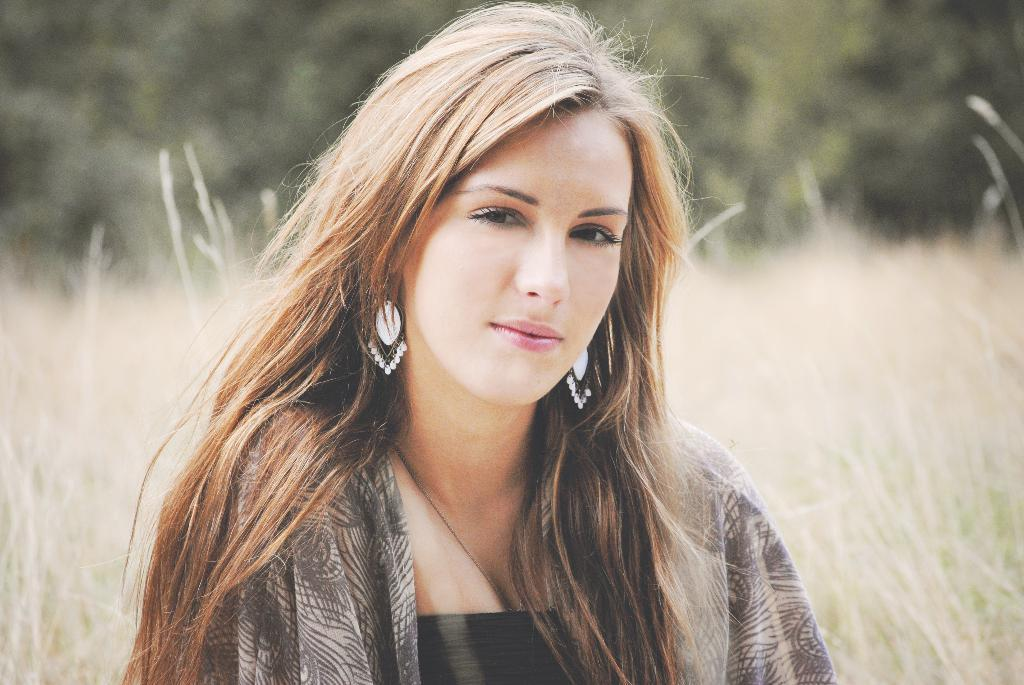Who or what can be seen in the image? There is a person visible in the image. Where is the person located? The person is on the grass. What type of sugar is being used by the woman in the image? There is no woman or sugar present in the image; it only features a person on the grass. 